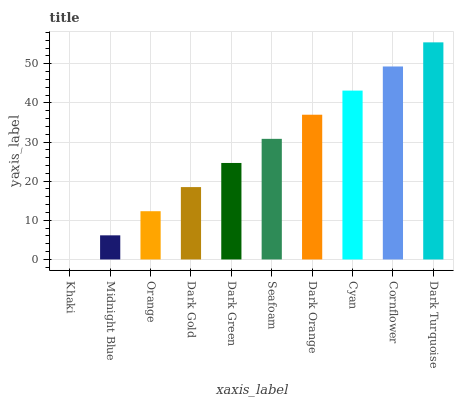Is Khaki the minimum?
Answer yes or no. Yes. Is Dark Turquoise the maximum?
Answer yes or no. Yes. Is Midnight Blue the minimum?
Answer yes or no. No. Is Midnight Blue the maximum?
Answer yes or no. No. Is Midnight Blue greater than Khaki?
Answer yes or no. Yes. Is Khaki less than Midnight Blue?
Answer yes or no. Yes. Is Khaki greater than Midnight Blue?
Answer yes or no. No. Is Midnight Blue less than Khaki?
Answer yes or no. No. Is Seafoam the high median?
Answer yes or no. Yes. Is Dark Green the low median?
Answer yes or no. Yes. Is Khaki the high median?
Answer yes or no. No. Is Midnight Blue the low median?
Answer yes or no. No. 